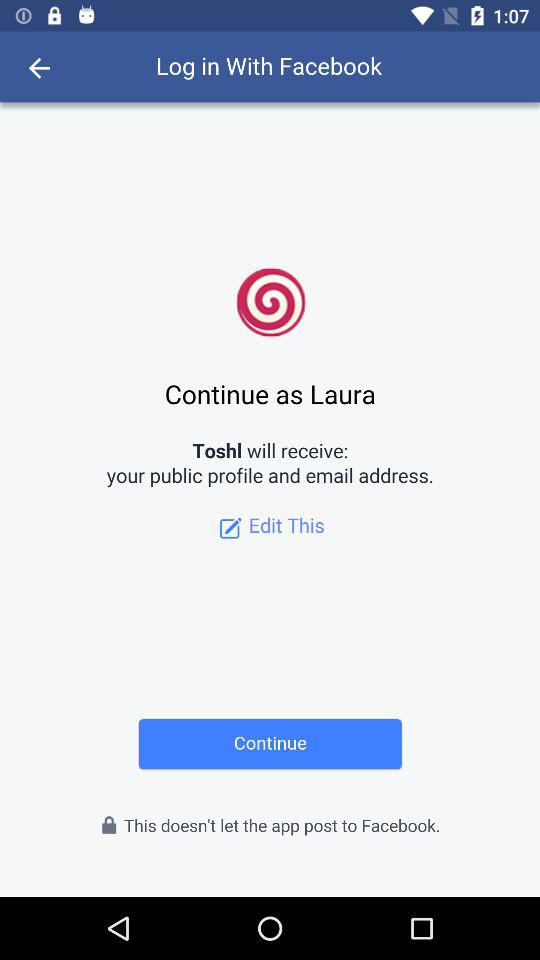What account can logging in be done with? Logging in can be done with "Facebook". 